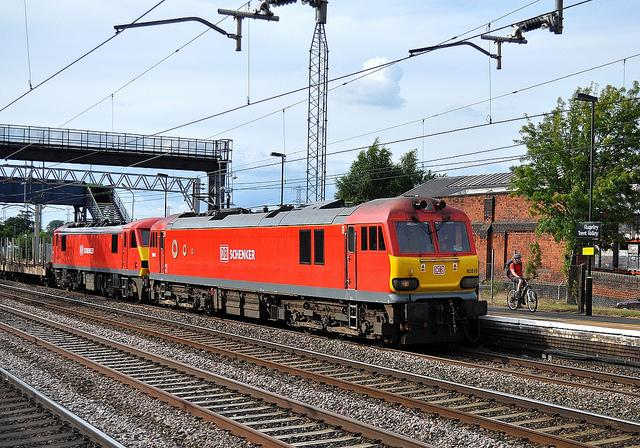Why has the cyclist covered his head? safety 